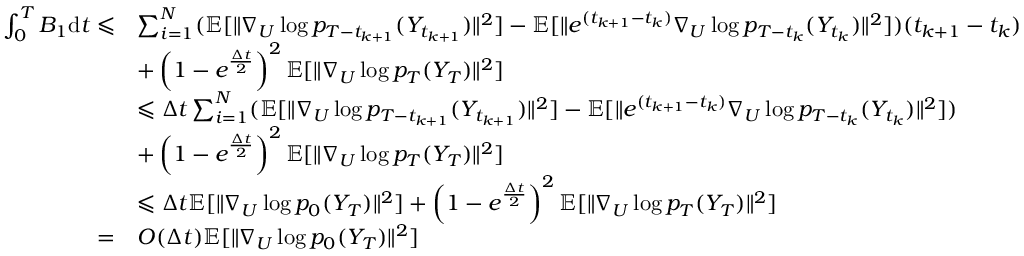<formula> <loc_0><loc_0><loc_500><loc_500>\begin{array} { r l } { \int _ { 0 } ^ { T } B _ { 1 } d t \leqslant } & { \sum _ { i = 1 } ^ { N } ( \mathbb { E } [ \| \nabla _ { U } \log p _ { T - t _ { k + 1 } } ( Y _ { t _ { k + 1 } } ) \| ^ { 2 } ] - \mathbb { E } [ \| e ^ { ( t _ { k + 1 } - t _ { k } ) } \nabla _ { U } \log p _ { T - t _ { k } } ( Y _ { t _ { k } } ) \| ^ { 2 } ] ) ( t _ { k + 1 } - t _ { k } ) } \\ & { + \left ( 1 - e ^ { \frac { \Delta t } { 2 } } \right ) ^ { 2 } \mathbb { E } [ \| \nabla _ { U } \log p _ { T } ( Y _ { T } ) \| ^ { 2 } ] } \\ & { \leqslant \Delta t \sum _ { i = 1 } ^ { N } ( \mathbb { E } [ \| \nabla _ { U } \log p _ { T - t _ { k + 1 } } ( Y _ { t _ { k + 1 } } ) \| ^ { 2 } ] - \mathbb { E } [ \| e ^ { ( t _ { k + 1 } - t _ { k } ) } \nabla _ { U } \log p _ { T - t _ { k } } ( Y _ { t _ { k } } ) \| ^ { 2 } ] ) } \\ & { + \left ( 1 - e ^ { \frac { \Delta t } { 2 } } \right ) ^ { 2 } \mathbb { E } [ \| \nabla _ { U } \log p _ { T } ( Y _ { T } ) \| ^ { 2 } ] } \\ & { \leqslant \Delta t \mathbb { E } [ \| \nabla _ { U } \log p _ { 0 } ( Y _ { T } ) \| ^ { 2 } ] + \left ( 1 - e ^ { \frac { \Delta t } { 2 } } \right ) ^ { 2 } \mathbb { E } [ \| \nabla _ { U } \log p _ { T } ( Y _ { T } ) \| ^ { 2 } ] } \\ { = } & { O ( \Delta t ) \mathbb { E } [ \| \nabla _ { U } \log p _ { 0 } ( Y _ { T } ) \| ^ { 2 } ] } \end{array}</formula> 